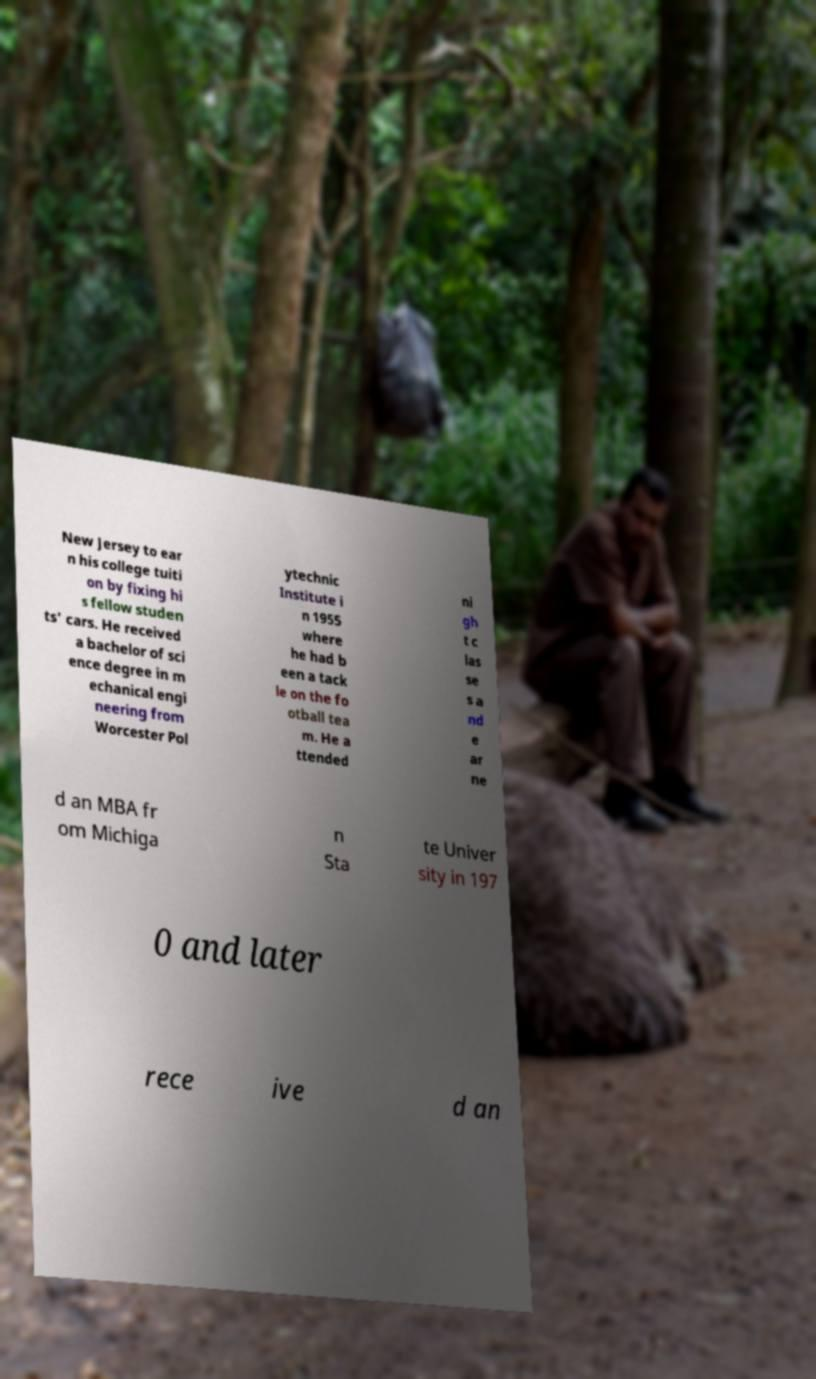What messages or text are displayed in this image? I need them in a readable, typed format. New Jersey to ear n his college tuiti on by fixing hi s fellow studen ts' cars. He received a bachelor of sci ence degree in m echanical engi neering from Worcester Pol ytechnic Institute i n 1955 where he had b een a tack le on the fo otball tea m. He a ttended ni gh t c las se s a nd e ar ne d an MBA fr om Michiga n Sta te Univer sity in 197 0 and later rece ive d an 